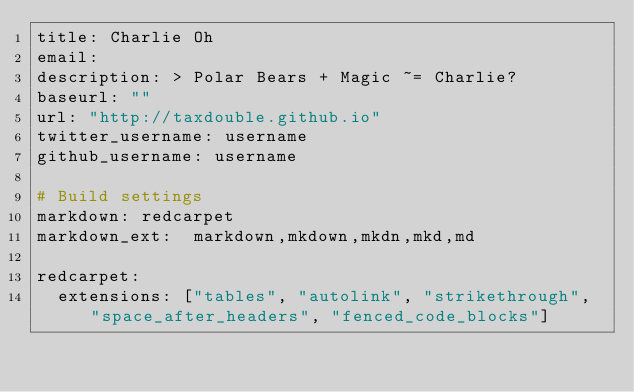<code> <loc_0><loc_0><loc_500><loc_500><_YAML_>title: Charlie Oh
email: 
description: > Polar Bears + Magic ~= Charlie?
baseurl: ""
url: "http://taxdouble.github.io"
twitter_username: username
github_username: username

# Build settings
markdown: redcarpet
markdown_ext:  markdown,mkdown,mkdn,mkd,md

redcarpet:
  extensions: ["tables", "autolink", "strikethrough", "space_after_headers", "fenced_code_blocks"]
</code> 